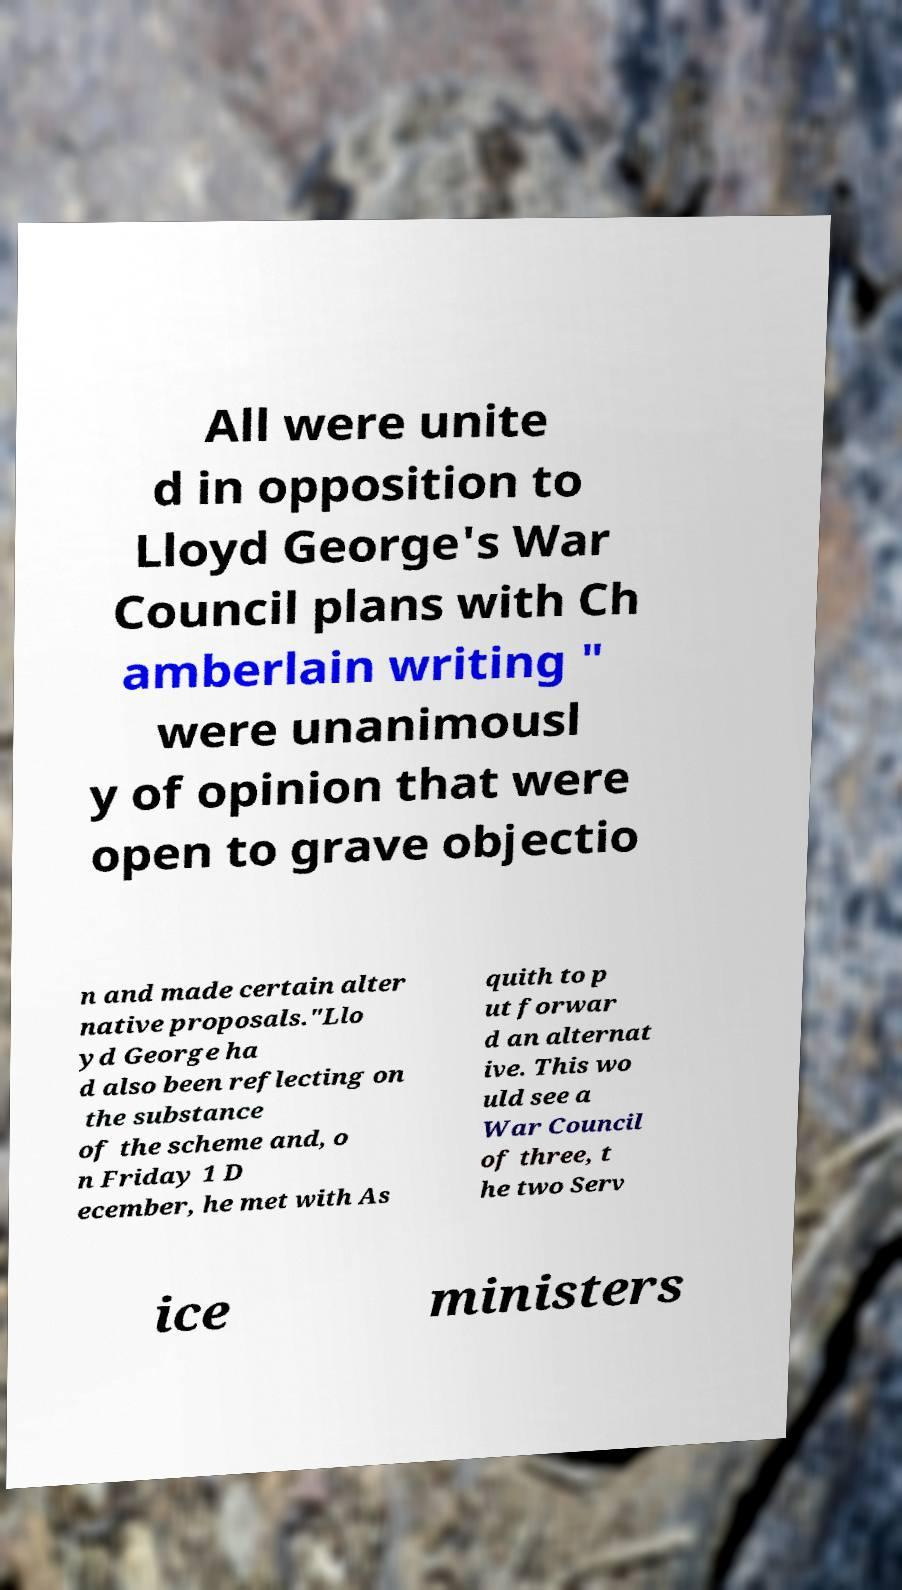I need the written content from this picture converted into text. Can you do that? All were unite d in opposition to Lloyd George's War Council plans with Ch amberlain writing " were unanimousl y of opinion that were open to grave objectio n and made certain alter native proposals."Llo yd George ha d also been reflecting on the substance of the scheme and, o n Friday 1 D ecember, he met with As quith to p ut forwar d an alternat ive. This wo uld see a War Council of three, t he two Serv ice ministers 